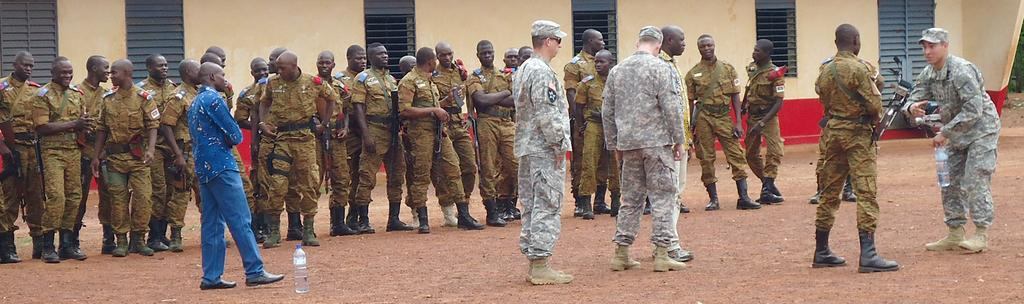What can be seen in the image involving people? There are people standing in the image. What object is located on the right side of the image? There is a bike on the right side of the image. What architectural features are visible in the background of the image? There are windows and a wall visible in the background of the image. What arithmetic problem is being solved by the people in the image? There is no indication in the image that the people are solving an arithmetic problem. How many borders are visible in the image? There are no borders visible in the image. 